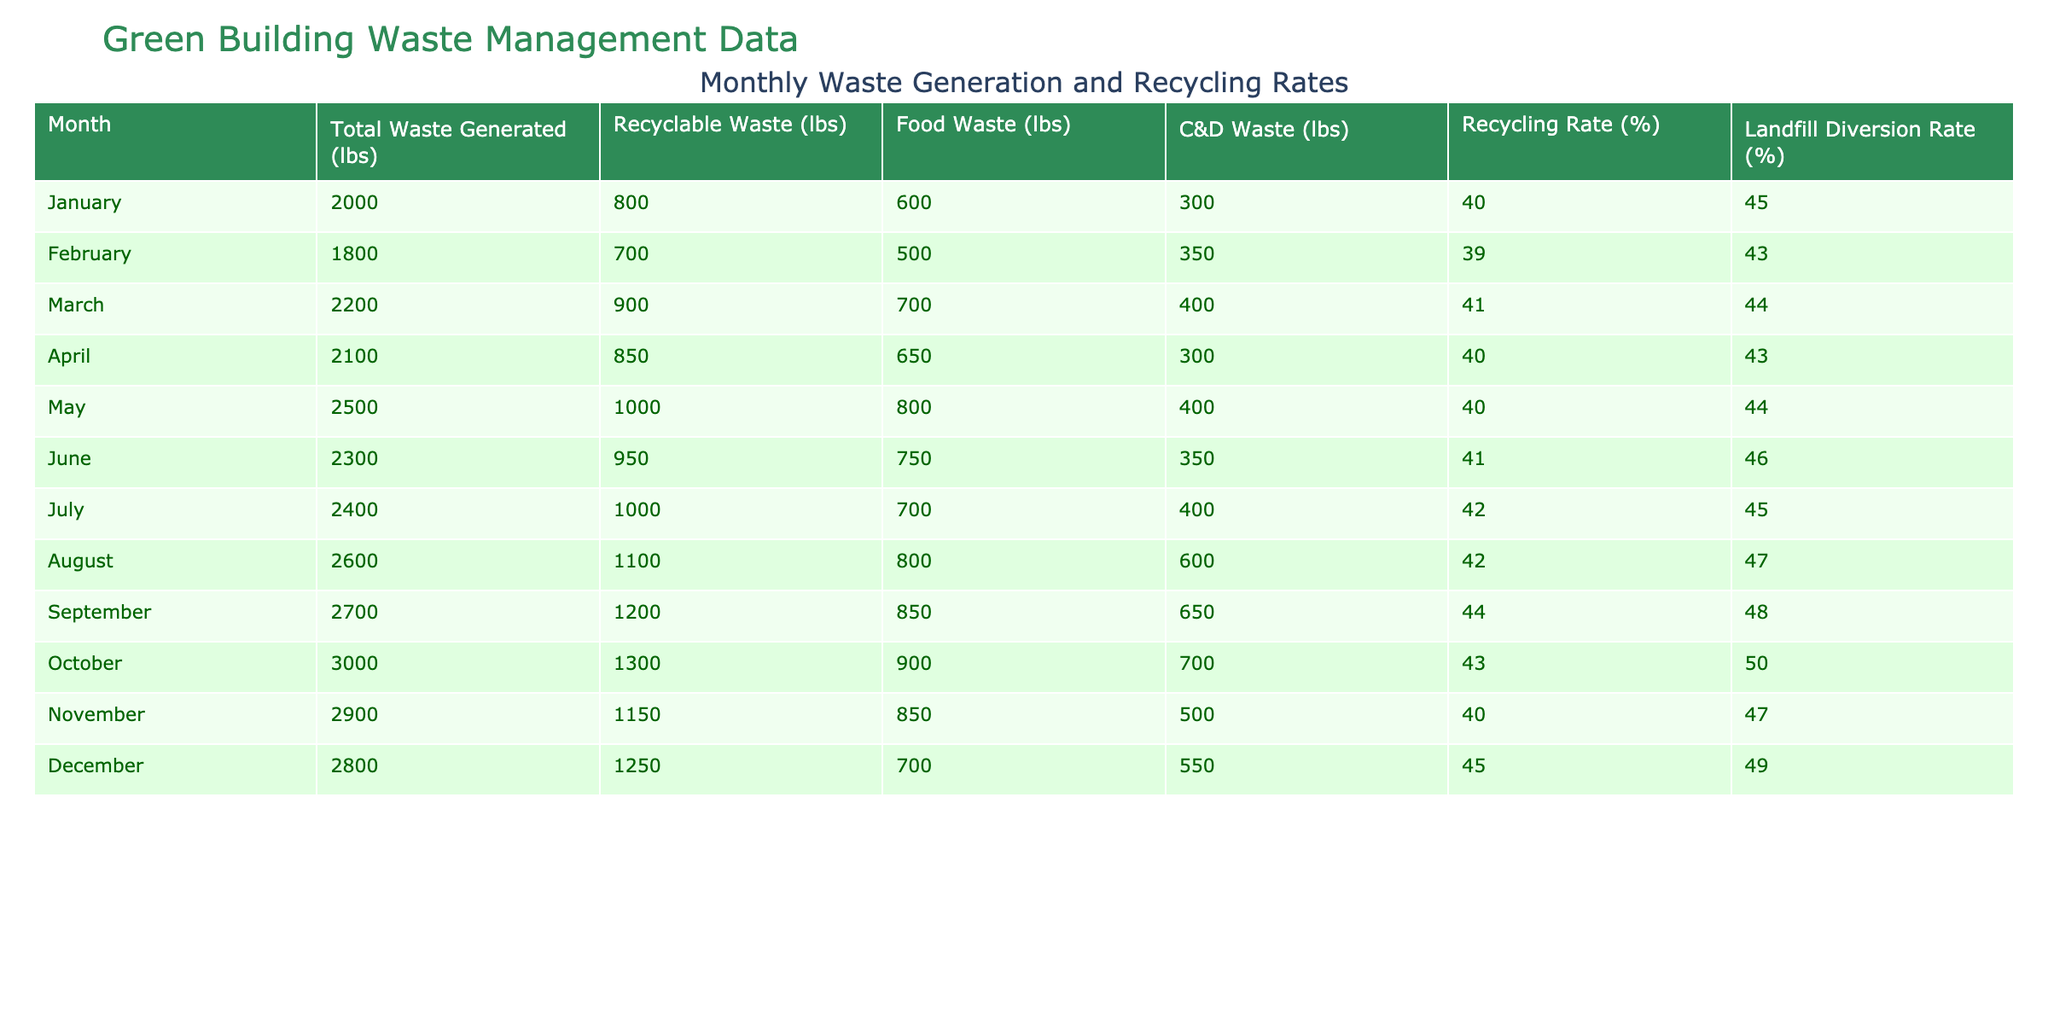What was the total waste generated in November? From the table, the total waste generated in November is listed directly under the "Total Waste Generated (lbs)" column for that month. It shows a value of 2900 lbs.
Answer: 2900 lbs What was the recycling rate in September? The recycling rate for September can be found in the "Recycling Rate (%)" column for that month. The value is 44%.
Answer: 44% Which month had the highest total waste generated? By scanning the "Total Waste Generated (lbs)" column, the highest value found is for October, with a total waste generation of 3000 lbs, which is greater than all other months.
Answer: October What is the average recycling rate across all months? To calculate the average recycling rate, add all the monthly values in the "Recycling Rate (%)" column and divide by the number of months, which is 12. The sum of the recycling rates is 490%, so the average is 490% / 12 = approximately 40.83%.
Answer: 40.83% Did the recycling rate exceed 43% in the last quarter (October to December)? In the last quarter, the recycling rates for October, November, and December are 43%, 40%, and 45%, respectively. Therefore, only December exceeds 43%, while October is equal, and November is below that rate.
Answer: Yes, December exceeded 43% In which month was the food waste generated the highest? By looking for the largest value in the "Food Waste (lbs)" column, we see that March has the highest value of 700 lbs for food waste.
Answer: March What was the total landfill diversion rate for the months of June and July combined? First, locate the landfill diversion rates for June (46%) and July (45%) in the "Landfill Diversion Rate (%)" column. Then, add these values together: 46% + 45% = 91%.
Answer: 91% Was the recyclable waste in April less than the food waste generated in the same month? The recyclable waste for April is 850 lbs as per the "Recyclable Waste (lbs)" column, while the food waste is recorded at 650 lbs in the "Food Waste (lbs)" column. Since 850 lbs is greater than 650 lbs, the statement is false.
Answer: No Which month showed a decrease in both total waste generated and recycling rate from the previous month? From the table, February shows a total waste generation of 1800 lbs (decreases from January's 2000 lbs) and a recycling rate of 39% (decreases from January's 40%). Both figures indicate a decrease.
Answer: February How many pounds of food waste were generated during the entire year? To find the total food waste for the year, sum all values in the "Food Waste (lbs)" column: 600 + 500 + 700 + 650 + 800 + 750 + 700 + 800 + 850 + 900 + 850 + 700 = 8750 lbs.
Answer: 8750 lbs 